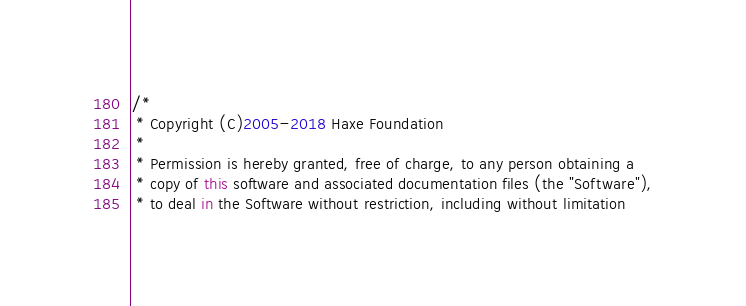<code> <loc_0><loc_0><loc_500><loc_500><_Haxe_>/*
 * Copyright (C)2005-2018 Haxe Foundation
 *
 * Permission is hereby granted, free of charge, to any person obtaining a
 * copy of this software and associated documentation files (the "Software"),
 * to deal in the Software without restriction, including without limitation</code> 